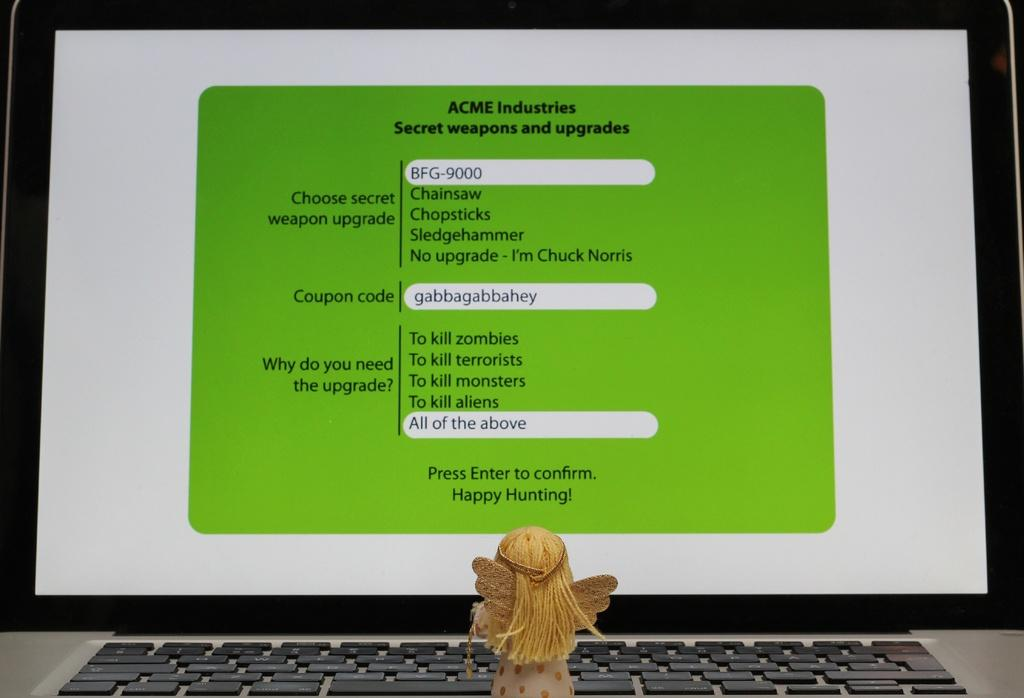<image>
Relay a brief, clear account of the picture shown. A laptop computer with the word Acme on the screen. 